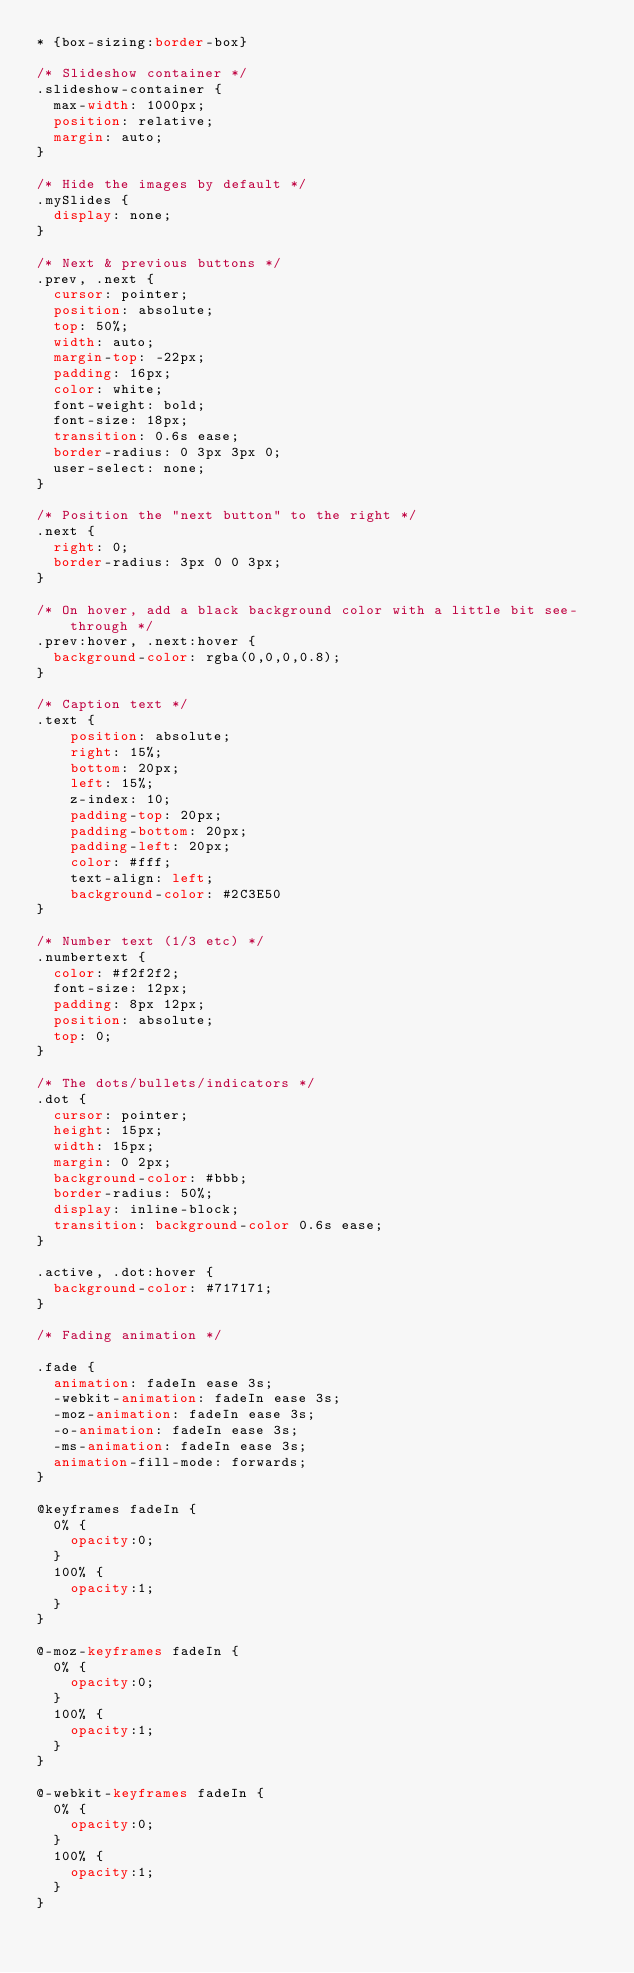Convert code to text. <code><loc_0><loc_0><loc_500><loc_500><_CSS_>* {box-sizing:border-box}

/* Slideshow container */
.slideshow-container {
  max-width: 1000px;
  position: relative;
  margin: auto;
}

/* Hide the images by default */
.mySlides {
  display: none;
}

/* Next & previous buttons */
.prev, .next {
  cursor: pointer;
  position: absolute;
  top: 50%;
  width: auto;
  margin-top: -22px;
  padding: 16px;
  color: white;
  font-weight: bold;
  font-size: 18px;
  transition: 0.6s ease;
  border-radius: 0 3px 3px 0;
  user-select: none;
}

/* Position the "next button" to the right */
.next {
  right: 0;
  border-radius: 3px 0 0 3px;
}

/* On hover, add a black background color with a little bit see-through */
.prev:hover, .next:hover {
  background-color: rgba(0,0,0,0.8);
}

/* Caption text */
.text {
    position: absolute;
    right: 15%;
    bottom: 20px;
    left: 15%;
    z-index: 10;
    padding-top: 20px;
    padding-bottom: 20px;
    padding-left: 20px;
    color: #fff;
    text-align: left;
    background-color: #2C3E50
}

/* Number text (1/3 etc) */
.numbertext {
  color: #f2f2f2;
  font-size: 12px;
  padding: 8px 12px;
  position: absolute;
  top: 0;
}

/* The dots/bullets/indicators */
.dot {
  cursor: pointer;
  height: 15px;
  width: 15px;
  margin: 0 2px;
  background-color: #bbb;
  border-radius: 50%;
  display: inline-block;
  transition: background-color 0.6s ease;
}

.active, .dot:hover {
  background-color: #717171;
}

/* Fading animation */

.fade {
  animation: fadeIn ease 3s;
  -webkit-animation: fadeIn ease 3s;
  -moz-animation: fadeIn ease 3s;
  -o-animation: fadeIn ease 3s;
  -ms-animation: fadeIn ease 3s;
  animation-fill-mode: forwards;
}

@keyframes fadeIn {
  0% {
    opacity:0;
  }
  100% {
    opacity:1;
  }
}

@-moz-keyframes fadeIn {
  0% {
    opacity:0;
  }
  100% {
    opacity:1;
  }
}

@-webkit-keyframes fadeIn {
  0% {
    opacity:0;
  }
  100% {
    opacity:1;
  }
}
</code> 